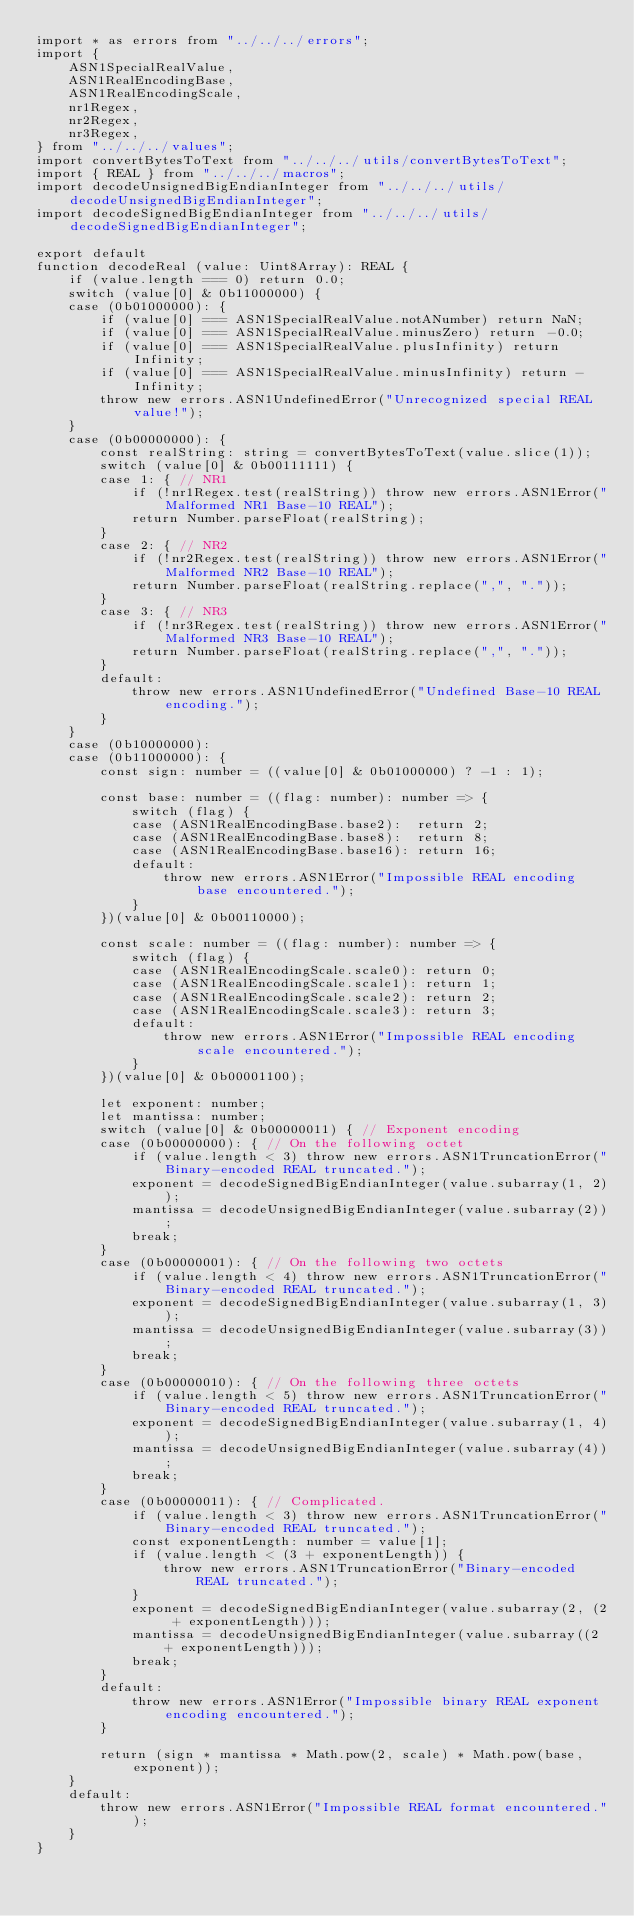<code> <loc_0><loc_0><loc_500><loc_500><_TypeScript_>import * as errors from "../../../errors";
import {
    ASN1SpecialRealValue,
    ASN1RealEncodingBase,
    ASN1RealEncodingScale,
    nr1Regex,
    nr2Regex,
    nr3Regex,
} from "../../../values";
import convertBytesToText from "../../../utils/convertBytesToText";
import { REAL } from "../../../macros";
import decodeUnsignedBigEndianInteger from "../../../utils/decodeUnsignedBigEndianInteger";
import decodeSignedBigEndianInteger from "../../../utils/decodeSignedBigEndianInteger";

export default
function decodeReal (value: Uint8Array): REAL {
    if (value.length === 0) return 0.0;
    switch (value[0] & 0b11000000) {
    case (0b01000000): {
        if (value[0] === ASN1SpecialRealValue.notANumber) return NaN;
        if (value[0] === ASN1SpecialRealValue.minusZero) return -0.0;
        if (value[0] === ASN1SpecialRealValue.plusInfinity) return Infinity;
        if (value[0] === ASN1SpecialRealValue.minusInfinity) return -Infinity;
        throw new errors.ASN1UndefinedError("Unrecognized special REAL value!");
    }
    case (0b00000000): {
        const realString: string = convertBytesToText(value.slice(1));
        switch (value[0] & 0b00111111) {
        case 1: { // NR1
            if (!nr1Regex.test(realString)) throw new errors.ASN1Error("Malformed NR1 Base-10 REAL");
            return Number.parseFloat(realString);
        }
        case 2: { // NR2
            if (!nr2Regex.test(realString)) throw new errors.ASN1Error("Malformed NR2 Base-10 REAL");
            return Number.parseFloat(realString.replace(",", "."));
        }
        case 3: { // NR3
            if (!nr3Regex.test(realString)) throw new errors.ASN1Error("Malformed NR3 Base-10 REAL");
            return Number.parseFloat(realString.replace(",", "."));
        }
        default:
            throw new errors.ASN1UndefinedError("Undefined Base-10 REAL encoding.");
        }
    }
    case (0b10000000):
    case (0b11000000): {
        const sign: number = ((value[0] & 0b01000000) ? -1 : 1);

        const base: number = ((flag: number): number => {
            switch (flag) {
            case (ASN1RealEncodingBase.base2):  return 2;
            case (ASN1RealEncodingBase.base8):  return 8;
            case (ASN1RealEncodingBase.base16): return 16;
            default:
                throw new errors.ASN1Error("Impossible REAL encoding base encountered.");
            }
        })(value[0] & 0b00110000);

        const scale: number = ((flag: number): number => {
            switch (flag) {
            case (ASN1RealEncodingScale.scale0): return 0;
            case (ASN1RealEncodingScale.scale1): return 1;
            case (ASN1RealEncodingScale.scale2): return 2;
            case (ASN1RealEncodingScale.scale3): return 3;
            default:
                throw new errors.ASN1Error("Impossible REAL encoding scale encountered.");
            }
        })(value[0] & 0b00001100);

        let exponent: number;
        let mantissa: number;
        switch (value[0] & 0b00000011) { // Exponent encoding
        case (0b00000000): { // On the following octet
            if (value.length < 3) throw new errors.ASN1TruncationError("Binary-encoded REAL truncated.");
            exponent = decodeSignedBigEndianInteger(value.subarray(1, 2));
            mantissa = decodeUnsignedBigEndianInteger(value.subarray(2));
            break;
        }
        case (0b00000001): { // On the following two octets
            if (value.length < 4) throw new errors.ASN1TruncationError("Binary-encoded REAL truncated.");
            exponent = decodeSignedBigEndianInteger(value.subarray(1, 3));
            mantissa = decodeUnsignedBigEndianInteger(value.subarray(3));
            break;
        }
        case (0b00000010): { // On the following three octets
            if (value.length < 5) throw new errors.ASN1TruncationError("Binary-encoded REAL truncated.");
            exponent = decodeSignedBigEndianInteger(value.subarray(1, 4));
            mantissa = decodeUnsignedBigEndianInteger(value.subarray(4));
            break;
        }
        case (0b00000011): { // Complicated.
            if (value.length < 3) throw new errors.ASN1TruncationError("Binary-encoded REAL truncated.");
            const exponentLength: number = value[1];
            if (value.length < (3 + exponentLength)) {
                throw new errors.ASN1TruncationError("Binary-encoded REAL truncated.");
            }
            exponent = decodeSignedBigEndianInteger(value.subarray(2, (2 + exponentLength)));
            mantissa = decodeUnsignedBigEndianInteger(value.subarray((2 + exponentLength)));
            break;
        }
        default:
            throw new errors.ASN1Error("Impossible binary REAL exponent encoding encountered.");
        }

        return (sign * mantissa * Math.pow(2, scale) * Math.pow(base, exponent));
    }
    default:
        throw new errors.ASN1Error("Impossible REAL format encountered.");
    }
}
</code> 